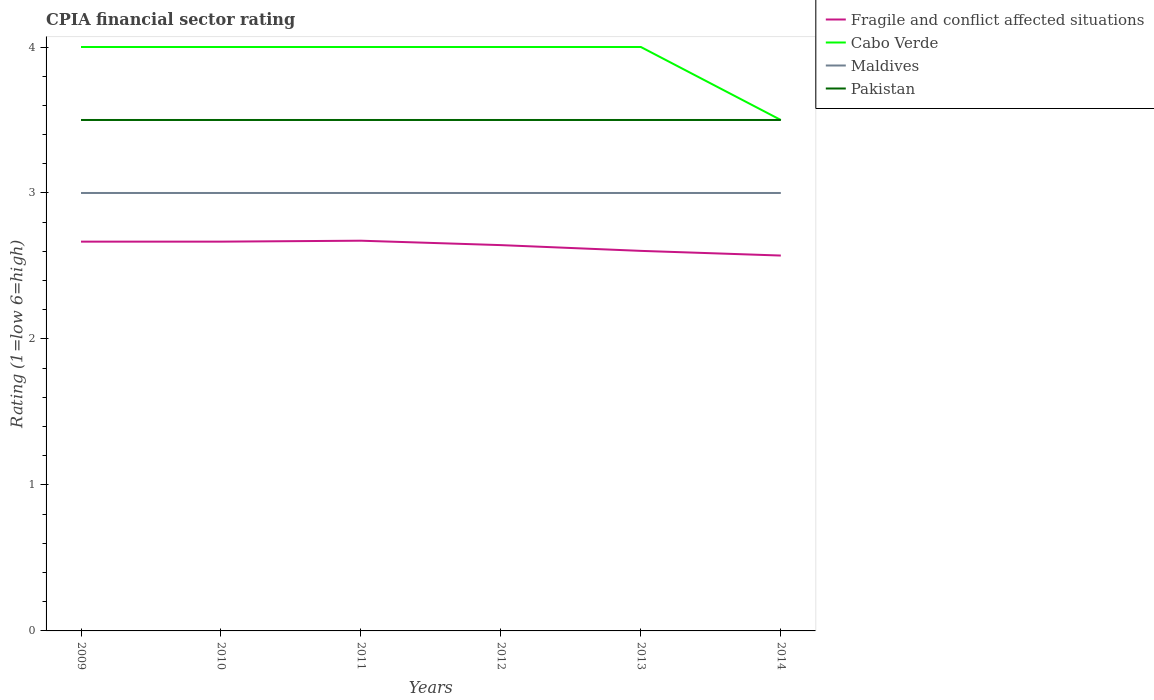How many different coloured lines are there?
Your answer should be very brief. 4. Is the number of lines equal to the number of legend labels?
Your answer should be very brief. Yes. Across all years, what is the maximum CPIA rating in Fragile and conflict affected situations?
Your answer should be very brief. 2.57. What is the difference between the highest and the second highest CPIA rating in Maldives?
Make the answer very short. 0. What is the difference between the highest and the lowest CPIA rating in Pakistan?
Your response must be concise. 0. Is the CPIA rating in Pakistan strictly greater than the CPIA rating in Fragile and conflict affected situations over the years?
Offer a very short reply. No. What is the difference between two consecutive major ticks on the Y-axis?
Your answer should be compact. 1. Does the graph contain any zero values?
Your answer should be compact. No. Does the graph contain grids?
Your response must be concise. No. How are the legend labels stacked?
Keep it short and to the point. Vertical. What is the title of the graph?
Provide a succinct answer. CPIA financial sector rating. What is the label or title of the X-axis?
Your response must be concise. Years. What is the label or title of the Y-axis?
Ensure brevity in your answer.  Rating (1=low 6=high). What is the Rating (1=low 6=high) in Fragile and conflict affected situations in 2009?
Your response must be concise. 2.67. What is the Rating (1=low 6=high) in Maldives in 2009?
Give a very brief answer. 3. What is the Rating (1=low 6=high) of Pakistan in 2009?
Provide a short and direct response. 3.5. What is the Rating (1=low 6=high) of Fragile and conflict affected situations in 2010?
Give a very brief answer. 2.67. What is the Rating (1=low 6=high) of Cabo Verde in 2010?
Ensure brevity in your answer.  4. What is the Rating (1=low 6=high) in Fragile and conflict affected situations in 2011?
Keep it short and to the point. 2.67. What is the Rating (1=low 6=high) of Pakistan in 2011?
Your answer should be compact. 3.5. What is the Rating (1=low 6=high) of Fragile and conflict affected situations in 2012?
Provide a short and direct response. 2.64. What is the Rating (1=low 6=high) in Cabo Verde in 2012?
Your response must be concise. 4. What is the Rating (1=low 6=high) in Fragile and conflict affected situations in 2013?
Make the answer very short. 2.6. What is the Rating (1=low 6=high) of Cabo Verde in 2013?
Make the answer very short. 4. What is the Rating (1=low 6=high) in Maldives in 2013?
Offer a terse response. 3. What is the Rating (1=low 6=high) in Pakistan in 2013?
Provide a short and direct response. 3.5. What is the Rating (1=low 6=high) of Fragile and conflict affected situations in 2014?
Provide a succinct answer. 2.57. What is the Rating (1=low 6=high) of Pakistan in 2014?
Your answer should be very brief. 3.5. Across all years, what is the maximum Rating (1=low 6=high) of Fragile and conflict affected situations?
Your response must be concise. 2.67. Across all years, what is the maximum Rating (1=low 6=high) in Maldives?
Your answer should be very brief. 3. Across all years, what is the maximum Rating (1=low 6=high) in Pakistan?
Provide a short and direct response. 3.5. Across all years, what is the minimum Rating (1=low 6=high) in Fragile and conflict affected situations?
Offer a terse response. 2.57. Across all years, what is the minimum Rating (1=low 6=high) in Cabo Verde?
Your response must be concise. 3.5. Across all years, what is the minimum Rating (1=low 6=high) of Maldives?
Ensure brevity in your answer.  3. What is the total Rating (1=low 6=high) in Fragile and conflict affected situations in the graph?
Make the answer very short. 15.82. What is the total Rating (1=low 6=high) of Pakistan in the graph?
Your response must be concise. 21. What is the difference between the Rating (1=low 6=high) in Pakistan in 2009 and that in 2010?
Provide a succinct answer. 0. What is the difference between the Rating (1=low 6=high) in Fragile and conflict affected situations in 2009 and that in 2011?
Your answer should be very brief. -0.01. What is the difference between the Rating (1=low 6=high) in Cabo Verde in 2009 and that in 2011?
Offer a terse response. 0. What is the difference between the Rating (1=low 6=high) of Maldives in 2009 and that in 2011?
Offer a very short reply. 0. What is the difference between the Rating (1=low 6=high) in Pakistan in 2009 and that in 2011?
Keep it short and to the point. 0. What is the difference between the Rating (1=low 6=high) of Fragile and conflict affected situations in 2009 and that in 2012?
Give a very brief answer. 0.02. What is the difference between the Rating (1=low 6=high) in Pakistan in 2009 and that in 2012?
Offer a very short reply. 0. What is the difference between the Rating (1=low 6=high) in Fragile and conflict affected situations in 2009 and that in 2013?
Make the answer very short. 0.06. What is the difference between the Rating (1=low 6=high) in Maldives in 2009 and that in 2013?
Make the answer very short. 0. What is the difference between the Rating (1=low 6=high) in Fragile and conflict affected situations in 2009 and that in 2014?
Your answer should be very brief. 0.1. What is the difference between the Rating (1=low 6=high) in Cabo Verde in 2009 and that in 2014?
Keep it short and to the point. 0.5. What is the difference between the Rating (1=low 6=high) of Maldives in 2009 and that in 2014?
Give a very brief answer. 0. What is the difference between the Rating (1=low 6=high) of Pakistan in 2009 and that in 2014?
Make the answer very short. 0. What is the difference between the Rating (1=low 6=high) in Fragile and conflict affected situations in 2010 and that in 2011?
Your answer should be very brief. -0.01. What is the difference between the Rating (1=low 6=high) in Pakistan in 2010 and that in 2011?
Your answer should be compact. 0. What is the difference between the Rating (1=low 6=high) in Fragile and conflict affected situations in 2010 and that in 2012?
Keep it short and to the point. 0.02. What is the difference between the Rating (1=low 6=high) in Fragile and conflict affected situations in 2010 and that in 2013?
Your answer should be very brief. 0.06. What is the difference between the Rating (1=low 6=high) in Cabo Verde in 2010 and that in 2013?
Offer a very short reply. 0. What is the difference between the Rating (1=low 6=high) in Maldives in 2010 and that in 2013?
Your answer should be compact. 0. What is the difference between the Rating (1=low 6=high) in Pakistan in 2010 and that in 2013?
Keep it short and to the point. 0. What is the difference between the Rating (1=low 6=high) of Fragile and conflict affected situations in 2010 and that in 2014?
Provide a short and direct response. 0.1. What is the difference between the Rating (1=low 6=high) in Cabo Verde in 2010 and that in 2014?
Your answer should be very brief. 0.5. What is the difference between the Rating (1=low 6=high) in Maldives in 2010 and that in 2014?
Your answer should be very brief. 0. What is the difference between the Rating (1=low 6=high) in Fragile and conflict affected situations in 2011 and that in 2012?
Give a very brief answer. 0.03. What is the difference between the Rating (1=low 6=high) of Cabo Verde in 2011 and that in 2012?
Give a very brief answer. 0. What is the difference between the Rating (1=low 6=high) in Maldives in 2011 and that in 2012?
Your response must be concise. 0. What is the difference between the Rating (1=low 6=high) of Pakistan in 2011 and that in 2012?
Make the answer very short. 0. What is the difference between the Rating (1=low 6=high) of Fragile and conflict affected situations in 2011 and that in 2013?
Keep it short and to the point. 0.07. What is the difference between the Rating (1=low 6=high) of Maldives in 2011 and that in 2013?
Provide a short and direct response. 0. What is the difference between the Rating (1=low 6=high) of Fragile and conflict affected situations in 2011 and that in 2014?
Make the answer very short. 0.1. What is the difference between the Rating (1=low 6=high) in Maldives in 2011 and that in 2014?
Your response must be concise. 0. What is the difference between the Rating (1=low 6=high) in Fragile and conflict affected situations in 2012 and that in 2013?
Ensure brevity in your answer.  0.04. What is the difference between the Rating (1=low 6=high) of Maldives in 2012 and that in 2013?
Give a very brief answer. 0. What is the difference between the Rating (1=low 6=high) of Pakistan in 2012 and that in 2013?
Make the answer very short. 0. What is the difference between the Rating (1=low 6=high) of Fragile and conflict affected situations in 2012 and that in 2014?
Make the answer very short. 0.07. What is the difference between the Rating (1=low 6=high) in Cabo Verde in 2012 and that in 2014?
Ensure brevity in your answer.  0.5. What is the difference between the Rating (1=low 6=high) in Fragile and conflict affected situations in 2013 and that in 2014?
Keep it short and to the point. 0.03. What is the difference between the Rating (1=low 6=high) of Cabo Verde in 2013 and that in 2014?
Give a very brief answer. 0.5. What is the difference between the Rating (1=low 6=high) of Maldives in 2013 and that in 2014?
Make the answer very short. 0. What is the difference between the Rating (1=low 6=high) in Fragile and conflict affected situations in 2009 and the Rating (1=low 6=high) in Cabo Verde in 2010?
Keep it short and to the point. -1.33. What is the difference between the Rating (1=low 6=high) of Fragile and conflict affected situations in 2009 and the Rating (1=low 6=high) of Maldives in 2010?
Ensure brevity in your answer.  -0.33. What is the difference between the Rating (1=low 6=high) in Cabo Verde in 2009 and the Rating (1=low 6=high) in Maldives in 2010?
Provide a short and direct response. 1. What is the difference between the Rating (1=low 6=high) in Cabo Verde in 2009 and the Rating (1=low 6=high) in Pakistan in 2010?
Ensure brevity in your answer.  0.5. What is the difference between the Rating (1=low 6=high) in Fragile and conflict affected situations in 2009 and the Rating (1=low 6=high) in Cabo Verde in 2011?
Make the answer very short. -1.33. What is the difference between the Rating (1=low 6=high) of Cabo Verde in 2009 and the Rating (1=low 6=high) of Maldives in 2011?
Make the answer very short. 1. What is the difference between the Rating (1=low 6=high) in Fragile and conflict affected situations in 2009 and the Rating (1=low 6=high) in Cabo Verde in 2012?
Your answer should be very brief. -1.33. What is the difference between the Rating (1=low 6=high) in Fragile and conflict affected situations in 2009 and the Rating (1=low 6=high) in Pakistan in 2012?
Provide a succinct answer. -0.83. What is the difference between the Rating (1=low 6=high) of Maldives in 2009 and the Rating (1=low 6=high) of Pakistan in 2012?
Offer a terse response. -0.5. What is the difference between the Rating (1=low 6=high) of Fragile and conflict affected situations in 2009 and the Rating (1=low 6=high) of Cabo Verde in 2013?
Give a very brief answer. -1.33. What is the difference between the Rating (1=low 6=high) of Fragile and conflict affected situations in 2009 and the Rating (1=low 6=high) of Maldives in 2013?
Your answer should be compact. -0.33. What is the difference between the Rating (1=low 6=high) in Fragile and conflict affected situations in 2009 and the Rating (1=low 6=high) in Pakistan in 2013?
Your answer should be very brief. -0.83. What is the difference between the Rating (1=low 6=high) in Maldives in 2009 and the Rating (1=low 6=high) in Pakistan in 2013?
Offer a terse response. -0.5. What is the difference between the Rating (1=low 6=high) in Fragile and conflict affected situations in 2009 and the Rating (1=low 6=high) in Cabo Verde in 2014?
Keep it short and to the point. -0.83. What is the difference between the Rating (1=low 6=high) in Fragile and conflict affected situations in 2009 and the Rating (1=low 6=high) in Pakistan in 2014?
Your answer should be very brief. -0.83. What is the difference between the Rating (1=low 6=high) of Cabo Verde in 2009 and the Rating (1=low 6=high) of Pakistan in 2014?
Ensure brevity in your answer.  0.5. What is the difference between the Rating (1=low 6=high) in Maldives in 2009 and the Rating (1=low 6=high) in Pakistan in 2014?
Offer a terse response. -0.5. What is the difference between the Rating (1=low 6=high) in Fragile and conflict affected situations in 2010 and the Rating (1=low 6=high) in Cabo Verde in 2011?
Your answer should be compact. -1.33. What is the difference between the Rating (1=low 6=high) of Cabo Verde in 2010 and the Rating (1=low 6=high) of Maldives in 2011?
Keep it short and to the point. 1. What is the difference between the Rating (1=low 6=high) of Cabo Verde in 2010 and the Rating (1=low 6=high) of Pakistan in 2011?
Ensure brevity in your answer.  0.5. What is the difference between the Rating (1=low 6=high) of Maldives in 2010 and the Rating (1=low 6=high) of Pakistan in 2011?
Your answer should be very brief. -0.5. What is the difference between the Rating (1=low 6=high) in Fragile and conflict affected situations in 2010 and the Rating (1=low 6=high) in Cabo Verde in 2012?
Offer a very short reply. -1.33. What is the difference between the Rating (1=low 6=high) in Fragile and conflict affected situations in 2010 and the Rating (1=low 6=high) in Maldives in 2012?
Provide a short and direct response. -0.33. What is the difference between the Rating (1=low 6=high) in Fragile and conflict affected situations in 2010 and the Rating (1=low 6=high) in Pakistan in 2012?
Provide a short and direct response. -0.83. What is the difference between the Rating (1=low 6=high) in Cabo Verde in 2010 and the Rating (1=low 6=high) in Maldives in 2012?
Offer a terse response. 1. What is the difference between the Rating (1=low 6=high) of Maldives in 2010 and the Rating (1=low 6=high) of Pakistan in 2012?
Your answer should be compact. -0.5. What is the difference between the Rating (1=low 6=high) in Fragile and conflict affected situations in 2010 and the Rating (1=low 6=high) in Cabo Verde in 2013?
Your answer should be very brief. -1.33. What is the difference between the Rating (1=low 6=high) in Fragile and conflict affected situations in 2010 and the Rating (1=low 6=high) in Pakistan in 2013?
Ensure brevity in your answer.  -0.83. What is the difference between the Rating (1=low 6=high) of Cabo Verde in 2010 and the Rating (1=low 6=high) of Maldives in 2013?
Offer a very short reply. 1. What is the difference between the Rating (1=low 6=high) of Maldives in 2010 and the Rating (1=low 6=high) of Pakistan in 2013?
Your answer should be compact. -0.5. What is the difference between the Rating (1=low 6=high) in Cabo Verde in 2010 and the Rating (1=low 6=high) in Maldives in 2014?
Your answer should be very brief. 1. What is the difference between the Rating (1=low 6=high) in Cabo Verde in 2010 and the Rating (1=low 6=high) in Pakistan in 2014?
Provide a short and direct response. 0.5. What is the difference between the Rating (1=low 6=high) of Fragile and conflict affected situations in 2011 and the Rating (1=low 6=high) of Cabo Verde in 2012?
Give a very brief answer. -1.33. What is the difference between the Rating (1=low 6=high) in Fragile and conflict affected situations in 2011 and the Rating (1=low 6=high) in Maldives in 2012?
Give a very brief answer. -0.33. What is the difference between the Rating (1=low 6=high) of Fragile and conflict affected situations in 2011 and the Rating (1=low 6=high) of Pakistan in 2012?
Keep it short and to the point. -0.83. What is the difference between the Rating (1=low 6=high) of Cabo Verde in 2011 and the Rating (1=low 6=high) of Maldives in 2012?
Keep it short and to the point. 1. What is the difference between the Rating (1=low 6=high) in Maldives in 2011 and the Rating (1=low 6=high) in Pakistan in 2012?
Ensure brevity in your answer.  -0.5. What is the difference between the Rating (1=low 6=high) in Fragile and conflict affected situations in 2011 and the Rating (1=low 6=high) in Cabo Verde in 2013?
Your answer should be compact. -1.33. What is the difference between the Rating (1=low 6=high) of Fragile and conflict affected situations in 2011 and the Rating (1=low 6=high) of Maldives in 2013?
Your response must be concise. -0.33. What is the difference between the Rating (1=low 6=high) of Fragile and conflict affected situations in 2011 and the Rating (1=low 6=high) of Pakistan in 2013?
Provide a succinct answer. -0.83. What is the difference between the Rating (1=low 6=high) of Cabo Verde in 2011 and the Rating (1=low 6=high) of Maldives in 2013?
Give a very brief answer. 1. What is the difference between the Rating (1=low 6=high) in Maldives in 2011 and the Rating (1=low 6=high) in Pakistan in 2013?
Your answer should be very brief. -0.5. What is the difference between the Rating (1=low 6=high) of Fragile and conflict affected situations in 2011 and the Rating (1=low 6=high) of Cabo Verde in 2014?
Your answer should be very brief. -0.83. What is the difference between the Rating (1=low 6=high) in Fragile and conflict affected situations in 2011 and the Rating (1=low 6=high) in Maldives in 2014?
Provide a short and direct response. -0.33. What is the difference between the Rating (1=low 6=high) in Fragile and conflict affected situations in 2011 and the Rating (1=low 6=high) in Pakistan in 2014?
Your response must be concise. -0.83. What is the difference between the Rating (1=low 6=high) of Cabo Verde in 2011 and the Rating (1=low 6=high) of Maldives in 2014?
Your answer should be compact. 1. What is the difference between the Rating (1=low 6=high) of Maldives in 2011 and the Rating (1=low 6=high) of Pakistan in 2014?
Your response must be concise. -0.5. What is the difference between the Rating (1=low 6=high) of Fragile and conflict affected situations in 2012 and the Rating (1=low 6=high) of Cabo Verde in 2013?
Your answer should be compact. -1.36. What is the difference between the Rating (1=low 6=high) in Fragile and conflict affected situations in 2012 and the Rating (1=low 6=high) in Maldives in 2013?
Give a very brief answer. -0.36. What is the difference between the Rating (1=low 6=high) of Fragile and conflict affected situations in 2012 and the Rating (1=low 6=high) of Pakistan in 2013?
Your answer should be very brief. -0.86. What is the difference between the Rating (1=low 6=high) of Cabo Verde in 2012 and the Rating (1=low 6=high) of Maldives in 2013?
Your answer should be compact. 1. What is the difference between the Rating (1=low 6=high) in Maldives in 2012 and the Rating (1=low 6=high) in Pakistan in 2013?
Your answer should be compact. -0.5. What is the difference between the Rating (1=low 6=high) of Fragile and conflict affected situations in 2012 and the Rating (1=low 6=high) of Cabo Verde in 2014?
Make the answer very short. -0.86. What is the difference between the Rating (1=low 6=high) in Fragile and conflict affected situations in 2012 and the Rating (1=low 6=high) in Maldives in 2014?
Your answer should be very brief. -0.36. What is the difference between the Rating (1=low 6=high) in Fragile and conflict affected situations in 2012 and the Rating (1=low 6=high) in Pakistan in 2014?
Give a very brief answer. -0.86. What is the difference between the Rating (1=low 6=high) in Cabo Verde in 2012 and the Rating (1=low 6=high) in Maldives in 2014?
Your answer should be very brief. 1. What is the difference between the Rating (1=low 6=high) in Fragile and conflict affected situations in 2013 and the Rating (1=low 6=high) in Cabo Verde in 2014?
Your answer should be compact. -0.9. What is the difference between the Rating (1=low 6=high) in Fragile and conflict affected situations in 2013 and the Rating (1=low 6=high) in Maldives in 2014?
Provide a short and direct response. -0.4. What is the difference between the Rating (1=low 6=high) of Fragile and conflict affected situations in 2013 and the Rating (1=low 6=high) of Pakistan in 2014?
Provide a short and direct response. -0.9. What is the average Rating (1=low 6=high) in Fragile and conflict affected situations per year?
Ensure brevity in your answer.  2.64. What is the average Rating (1=low 6=high) in Cabo Verde per year?
Your answer should be very brief. 3.92. In the year 2009, what is the difference between the Rating (1=low 6=high) in Fragile and conflict affected situations and Rating (1=low 6=high) in Cabo Verde?
Offer a terse response. -1.33. In the year 2009, what is the difference between the Rating (1=low 6=high) of Fragile and conflict affected situations and Rating (1=low 6=high) of Maldives?
Your response must be concise. -0.33. In the year 2009, what is the difference between the Rating (1=low 6=high) of Fragile and conflict affected situations and Rating (1=low 6=high) of Pakistan?
Offer a very short reply. -0.83. In the year 2009, what is the difference between the Rating (1=low 6=high) in Cabo Verde and Rating (1=low 6=high) in Maldives?
Your answer should be very brief. 1. In the year 2009, what is the difference between the Rating (1=low 6=high) of Maldives and Rating (1=low 6=high) of Pakistan?
Your answer should be very brief. -0.5. In the year 2010, what is the difference between the Rating (1=low 6=high) of Fragile and conflict affected situations and Rating (1=low 6=high) of Cabo Verde?
Your answer should be very brief. -1.33. In the year 2010, what is the difference between the Rating (1=low 6=high) of Cabo Verde and Rating (1=low 6=high) of Pakistan?
Your answer should be very brief. 0.5. In the year 2011, what is the difference between the Rating (1=low 6=high) of Fragile and conflict affected situations and Rating (1=low 6=high) of Cabo Verde?
Ensure brevity in your answer.  -1.33. In the year 2011, what is the difference between the Rating (1=low 6=high) in Fragile and conflict affected situations and Rating (1=low 6=high) in Maldives?
Make the answer very short. -0.33. In the year 2011, what is the difference between the Rating (1=low 6=high) in Fragile and conflict affected situations and Rating (1=low 6=high) in Pakistan?
Your answer should be compact. -0.83. In the year 2011, what is the difference between the Rating (1=low 6=high) of Cabo Verde and Rating (1=low 6=high) of Maldives?
Provide a short and direct response. 1. In the year 2012, what is the difference between the Rating (1=low 6=high) in Fragile and conflict affected situations and Rating (1=low 6=high) in Cabo Verde?
Your answer should be very brief. -1.36. In the year 2012, what is the difference between the Rating (1=low 6=high) of Fragile and conflict affected situations and Rating (1=low 6=high) of Maldives?
Make the answer very short. -0.36. In the year 2012, what is the difference between the Rating (1=low 6=high) of Fragile and conflict affected situations and Rating (1=low 6=high) of Pakistan?
Make the answer very short. -0.86. In the year 2013, what is the difference between the Rating (1=low 6=high) of Fragile and conflict affected situations and Rating (1=low 6=high) of Cabo Verde?
Ensure brevity in your answer.  -1.4. In the year 2013, what is the difference between the Rating (1=low 6=high) of Fragile and conflict affected situations and Rating (1=low 6=high) of Maldives?
Your response must be concise. -0.4. In the year 2013, what is the difference between the Rating (1=low 6=high) of Fragile and conflict affected situations and Rating (1=low 6=high) of Pakistan?
Keep it short and to the point. -0.9. In the year 2013, what is the difference between the Rating (1=low 6=high) in Cabo Verde and Rating (1=low 6=high) in Maldives?
Make the answer very short. 1. In the year 2014, what is the difference between the Rating (1=low 6=high) of Fragile and conflict affected situations and Rating (1=low 6=high) of Cabo Verde?
Offer a terse response. -0.93. In the year 2014, what is the difference between the Rating (1=low 6=high) in Fragile and conflict affected situations and Rating (1=low 6=high) in Maldives?
Offer a very short reply. -0.43. In the year 2014, what is the difference between the Rating (1=low 6=high) of Fragile and conflict affected situations and Rating (1=low 6=high) of Pakistan?
Your answer should be very brief. -0.93. In the year 2014, what is the difference between the Rating (1=low 6=high) in Cabo Verde and Rating (1=low 6=high) in Maldives?
Offer a very short reply. 0.5. In the year 2014, what is the difference between the Rating (1=low 6=high) of Cabo Verde and Rating (1=low 6=high) of Pakistan?
Keep it short and to the point. 0. In the year 2014, what is the difference between the Rating (1=low 6=high) of Maldives and Rating (1=low 6=high) of Pakistan?
Offer a very short reply. -0.5. What is the ratio of the Rating (1=low 6=high) of Fragile and conflict affected situations in 2009 to that in 2010?
Provide a short and direct response. 1. What is the ratio of the Rating (1=low 6=high) of Cabo Verde in 2009 to that in 2010?
Offer a very short reply. 1. What is the ratio of the Rating (1=low 6=high) of Maldives in 2009 to that in 2011?
Offer a very short reply. 1. What is the ratio of the Rating (1=low 6=high) in Pakistan in 2009 to that in 2011?
Keep it short and to the point. 1. What is the ratio of the Rating (1=low 6=high) in Fragile and conflict affected situations in 2009 to that in 2012?
Give a very brief answer. 1.01. What is the ratio of the Rating (1=low 6=high) of Maldives in 2009 to that in 2012?
Give a very brief answer. 1. What is the ratio of the Rating (1=low 6=high) in Pakistan in 2009 to that in 2012?
Offer a terse response. 1. What is the ratio of the Rating (1=low 6=high) of Fragile and conflict affected situations in 2009 to that in 2013?
Offer a very short reply. 1.02. What is the ratio of the Rating (1=low 6=high) of Pakistan in 2009 to that in 2013?
Make the answer very short. 1. What is the ratio of the Rating (1=low 6=high) in Fragile and conflict affected situations in 2009 to that in 2014?
Keep it short and to the point. 1.04. What is the ratio of the Rating (1=low 6=high) in Maldives in 2009 to that in 2014?
Make the answer very short. 1. What is the ratio of the Rating (1=low 6=high) in Pakistan in 2009 to that in 2014?
Keep it short and to the point. 1. What is the ratio of the Rating (1=low 6=high) in Fragile and conflict affected situations in 2010 to that in 2011?
Your response must be concise. 1. What is the ratio of the Rating (1=low 6=high) of Cabo Verde in 2010 to that in 2011?
Your answer should be very brief. 1. What is the ratio of the Rating (1=low 6=high) in Maldives in 2010 to that in 2011?
Offer a very short reply. 1. What is the ratio of the Rating (1=low 6=high) of Pakistan in 2010 to that in 2011?
Ensure brevity in your answer.  1. What is the ratio of the Rating (1=low 6=high) in Cabo Verde in 2010 to that in 2012?
Offer a very short reply. 1. What is the ratio of the Rating (1=low 6=high) of Maldives in 2010 to that in 2012?
Your answer should be very brief. 1. What is the ratio of the Rating (1=low 6=high) in Pakistan in 2010 to that in 2012?
Make the answer very short. 1. What is the ratio of the Rating (1=low 6=high) of Fragile and conflict affected situations in 2010 to that in 2013?
Give a very brief answer. 1.02. What is the ratio of the Rating (1=low 6=high) of Cabo Verde in 2010 to that in 2013?
Ensure brevity in your answer.  1. What is the ratio of the Rating (1=low 6=high) in Pakistan in 2010 to that in 2013?
Provide a short and direct response. 1. What is the ratio of the Rating (1=low 6=high) in Cabo Verde in 2010 to that in 2014?
Provide a succinct answer. 1.14. What is the ratio of the Rating (1=low 6=high) in Fragile and conflict affected situations in 2011 to that in 2012?
Make the answer very short. 1.01. What is the ratio of the Rating (1=low 6=high) in Cabo Verde in 2011 to that in 2012?
Ensure brevity in your answer.  1. What is the ratio of the Rating (1=low 6=high) in Maldives in 2011 to that in 2012?
Your response must be concise. 1. What is the ratio of the Rating (1=low 6=high) of Pakistan in 2011 to that in 2012?
Your answer should be compact. 1. What is the ratio of the Rating (1=low 6=high) in Fragile and conflict affected situations in 2011 to that in 2013?
Give a very brief answer. 1.03. What is the ratio of the Rating (1=low 6=high) in Fragile and conflict affected situations in 2011 to that in 2014?
Your answer should be very brief. 1.04. What is the ratio of the Rating (1=low 6=high) in Cabo Verde in 2011 to that in 2014?
Offer a terse response. 1.14. What is the ratio of the Rating (1=low 6=high) of Maldives in 2011 to that in 2014?
Ensure brevity in your answer.  1. What is the ratio of the Rating (1=low 6=high) of Fragile and conflict affected situations in 2012 to that in 2013?
Offer a very short reply. 1.02. What is the ratio of the Rating (1=low 6=high) in Cabo Verde in 2012 to that in 2013?
Ensure brevity in your answer.  1. What is the ratio of the Rating (1=low 6=high) of Fragile and conflict affected situations in 2012 to that in 2014?
Give a very brief answer. 1.03. What is the ratio of the Rating (1=low 6=high) in Pakistan in 2012 to that in 2014?
Keep it short and to the point. 1. What is the ratio of the Rating (1=low 6=high) of Fragile and conflict affected situations in 2013 to that in 2014?
Make the answer very short. 1.01. What is the difference between the highest and the second highest Rating (1=low 6=high) in Fragile and conflict affected situations?
Your answer should be very brief. 0.01. What is the difference between the highest and the second highest Rating (1=low 6=high) in Cabo Verde?
Keep it short and to the point. 0. What is the difference between the highest and the second highest Rating (1=low 6=high) of Maldives?
Give a very brief answer. 0. What is the difference between the highest and the lowest Rating (1=low 6=high) of Fragile and conflict affected situations?
Keep it short and to the point. 0.1. What is the difference between the highest and the lowest Rating (1=low 6=high) in Maldives?
Keep it short and to the point. 0. What is the difference between the highest and the lowest Rating (1=low 6=high) of Pakistan?
Your response must be concise. 0. 